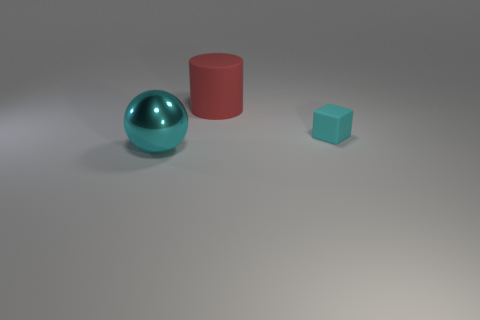There is a big object that is the same color as the block; what material is it?
Provide a succinct answer. Metal. What is the size of the cube?
Give a very brief answer. Small. Do the metallic thing and the rubber object that is in front of the big red cylinder have the same size?
Make the answer very short. No. There is a large thing behind the cyan thing in front of the cyan object that is behind the large metallic object; what color is it?
Ensure brevity in your answer.  Red. Are the cyan object right of the metallic object and the big cyan sphere made of the same material?
Give a very brief answer. No. How many other things are there of the same material as the small cyan block?
Your response must be concise. 1. There is a object that is the same size as the metal sphere; what is its material?
Offer a very short reply. Rubber. What shape is the cyan metallic thing that is the same size as the red thing?
Keep it short and to the point. Sphere. Does the cyan thing to the right of the rubber cylinder have the same material as the large sphere that is in front of the tiny rubber block?
Keep it short and to the point. No. There is a cyan thing right of the large metal object; is there a red cylinder that is in front of it?
Your answer should be compact. No. 